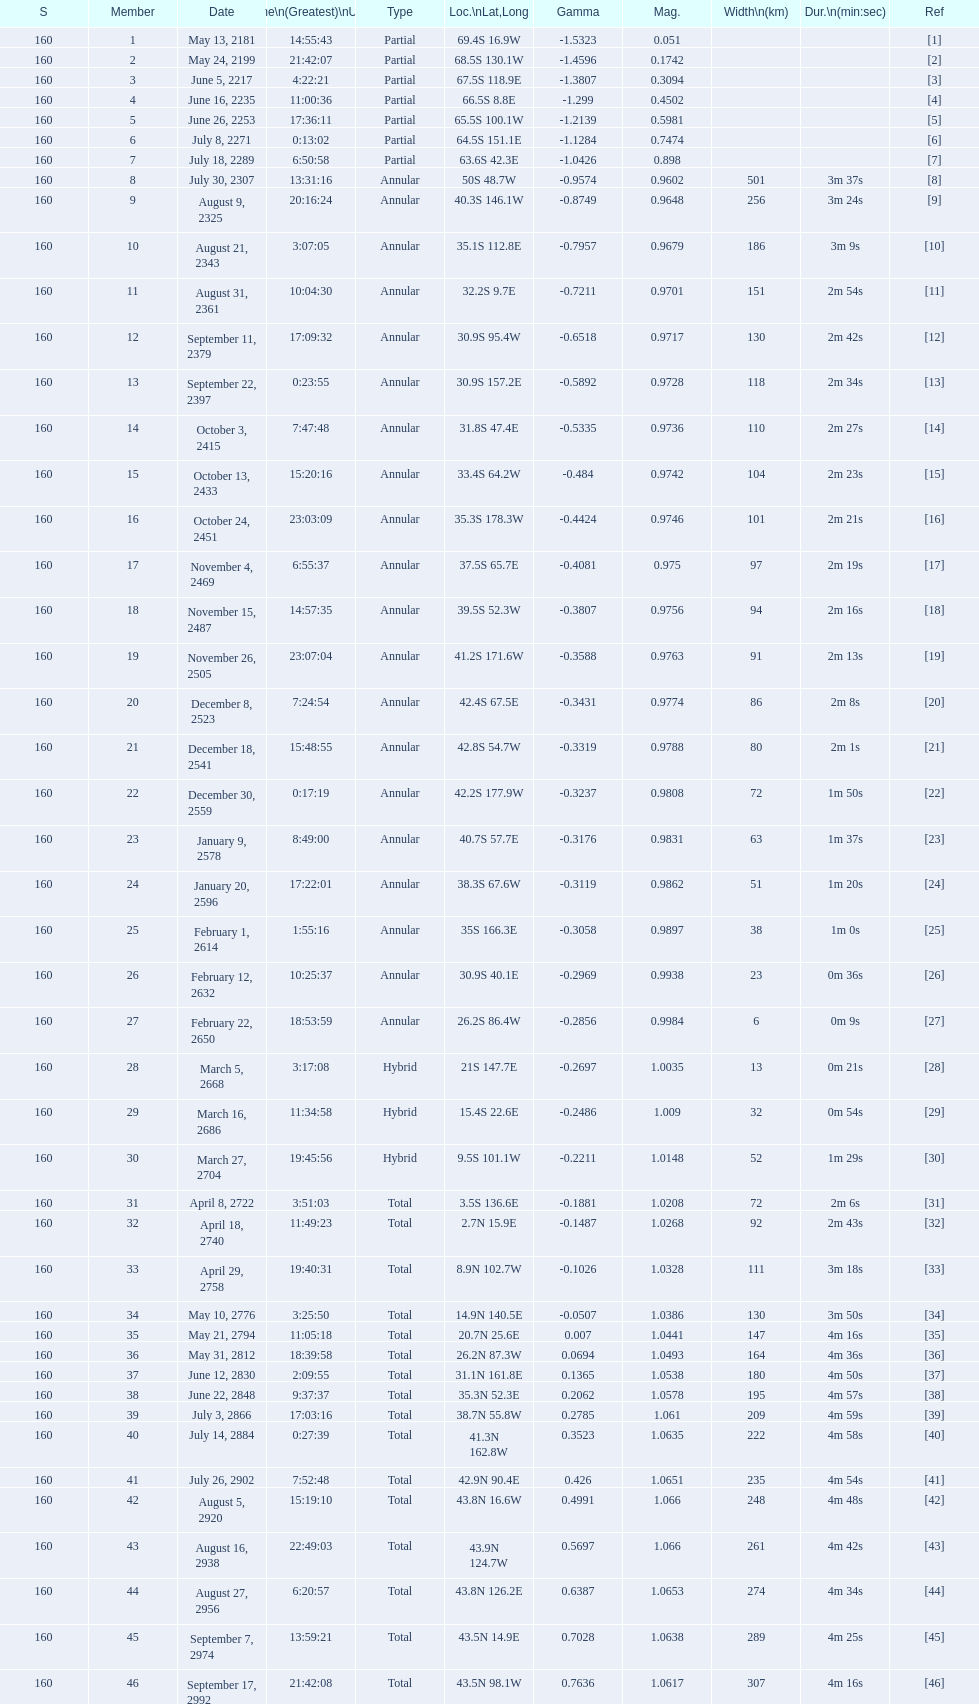Which one has a larger width, 8 or 21? 8. 